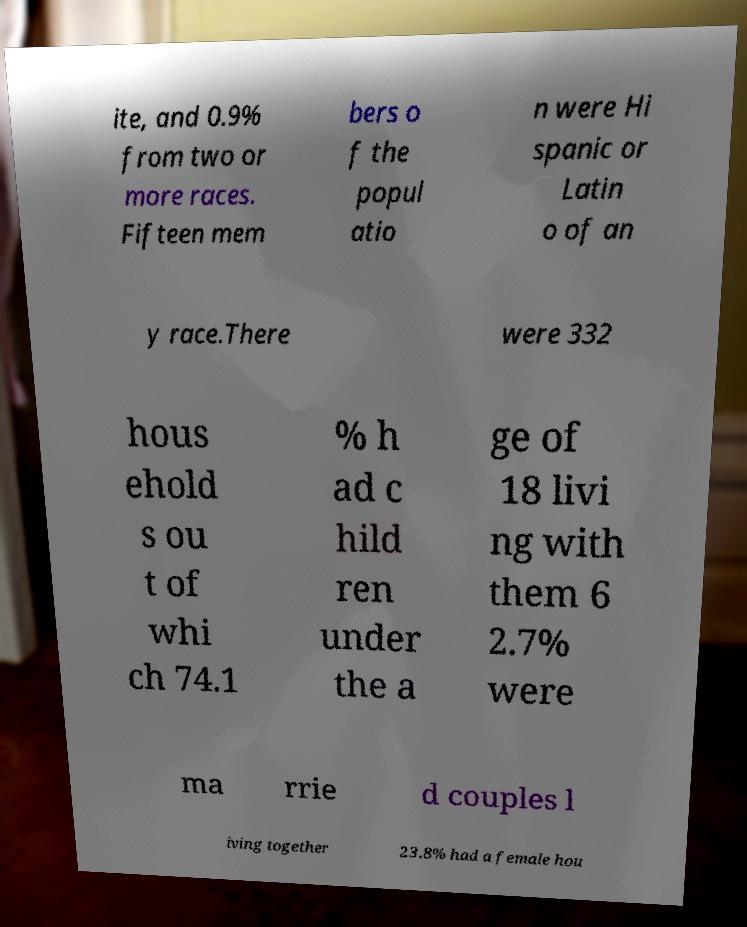Can you read and provide the text displayed in the image?This photo seems to have some interesting text. Can you extract and type it out for me? ite, and 0.9% from two or more races. Fifteen mem bers o f the popul atio n were Hi spanic or Latin o of an y race.There were 332 hous ehold s ou t of whi ch 74.1 % h ad c hild ren under the a ge of 18 livi ng with them 6 2.7% were ma rrie d couples l iving together 23.8% had a female hou 